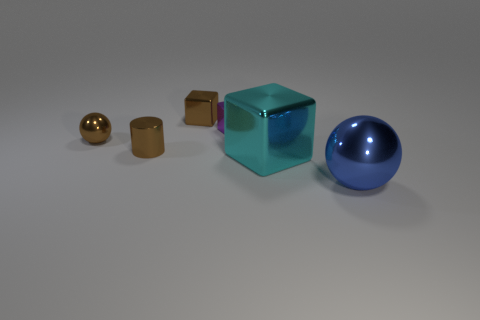How many objects are spheres left of the big cyan block or metal objects that are to the left of the blue metallic object?
Your answer should be compact. 5. Is the number of big cyan cubes to the right of the large metal ball less than the number of cyan things?
Your answer should be very brief. Yes. What is the material of the cylinder?
Make the answer very short. Metal. The tiny brown object in front of the metal sphere on the left side of the sphere that is to the right of the small purple shiny thing is made of what material?
Keep it short and to the point. Metal. Is the color of the small cylinder the same as the small cube behind the purple shiny cube?
Provide a short and direct response. Yes. The metal object that is in front of the big metallic thing behind the big sphere is what color?
Offer a terse response. Blue. What number of big blue matte spheres are there?
Offer a terse response. 0. What number of rubber things are either purple blocks or balls?
Offer a terse response. 0. How many cylinders are the same color as the small shiny sphere?
Your response must be concise. 1. There is a small block that is on the right side of the brown object that is behind the tiny sphere; what is its material?
Keep it short and to the point. Metal. 